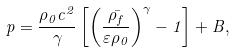<formula> <loc_0><loc_0><loc_500><loc_500>p = \frac { \rho _ { 0 } c ^ { 2 } } { \gamma } \left [ \left ( \frac { \bar { \rho _ { f } } } { \varepsilon \rho _ { 0 } } \right ) ^ { \gamma } - 1 \right ] + B ,</formula> 